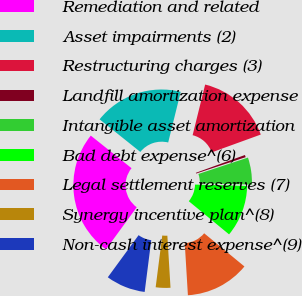Convert chart. <chart><loc_0><loc_0><loc_500><loc_500><pie_chart><fcel>Remediation and related<fcel>Asset impairments (2)<fcel>Restructuring charges (3)<fcel>Landfill amortization expense<fcel>Intangible asset amortization<fcel>Bad debt expense^(6)<fcel>Legal settlement reserves (7)<fcel>Synergy incentive plan^(8)<fcel>Non-cash interest expense^(9)<nl><fcel>25.69%<fcel>18.12%<fcel>15.6%<fcel>0.46%<fcel>5.5%<fcel>10.55%<fcel>13.07%<fcel>2.98%<fcel>8.03%<nl></chart> 